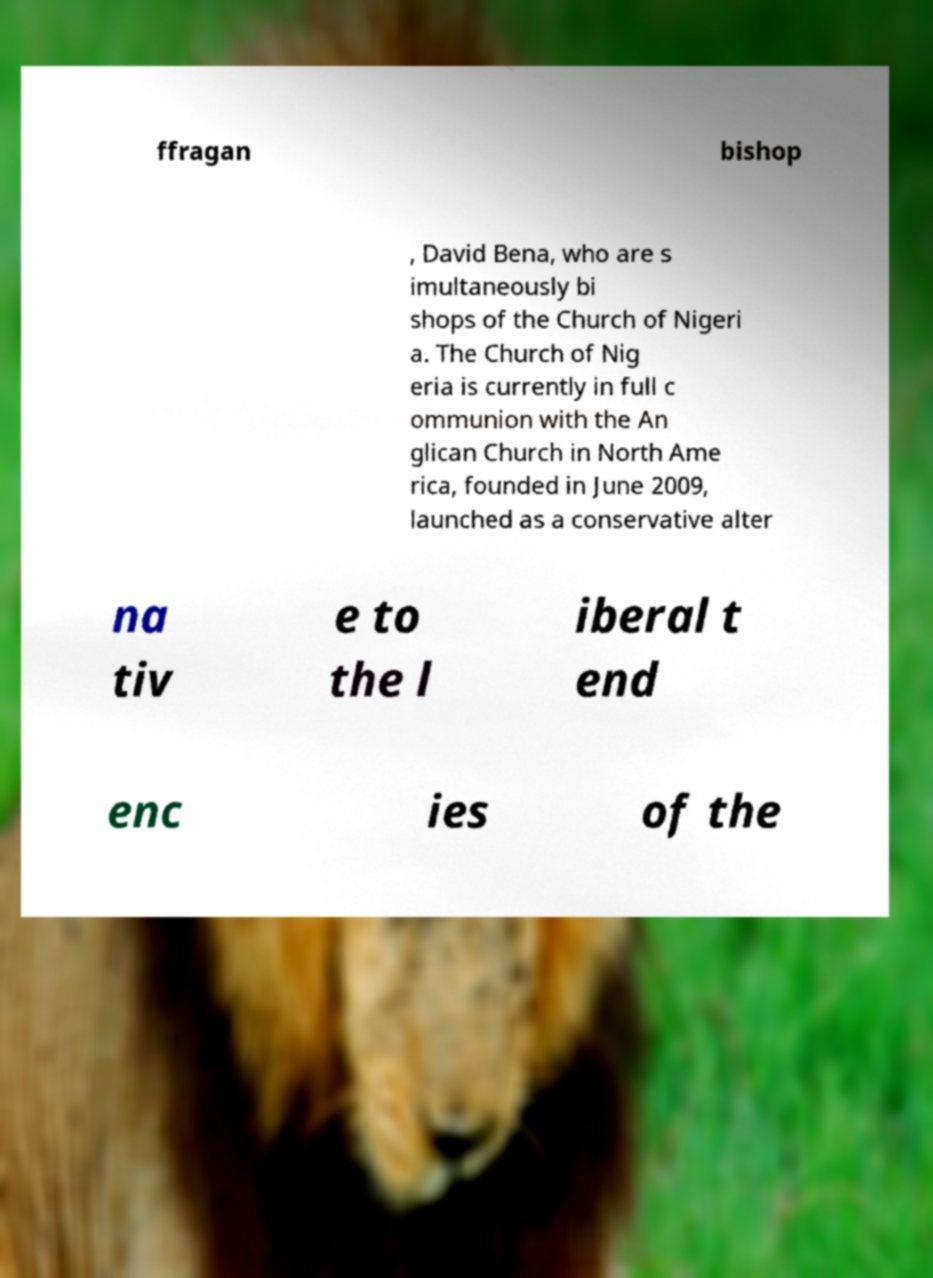Please identify and transcribe the text found in this image. ffragan bishop , David Bena, who are s imultaneously bi shops of the Church of Nigeri a. The Church of Nig eria is currently in full c ommunion with the An glican Church in North Ame rica, founded in June 2009, launched as a conservative alter na tiv e to the l iberal t end enc ies of the 